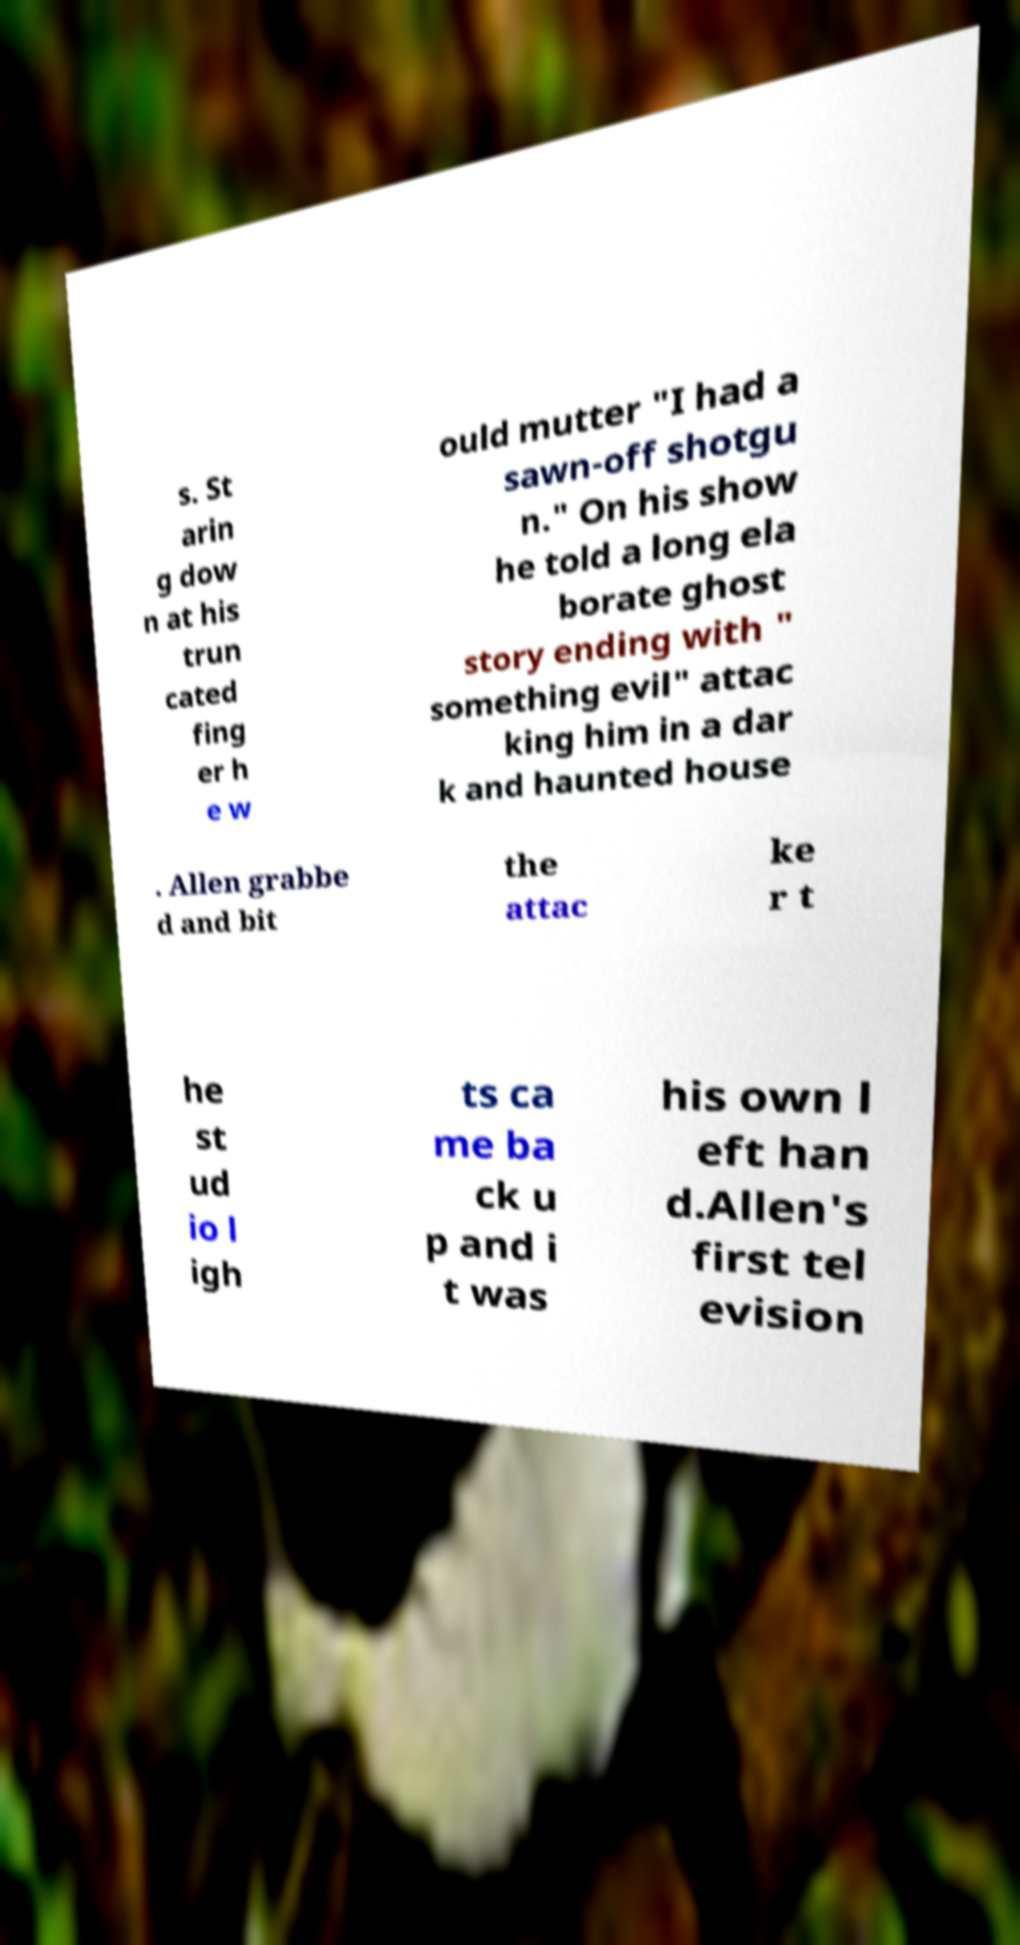For documentation purposes, I need the text within this image transcribed. Could you provide that? s. St arin g dow n at his trun cated fing er h e w ould mutter "I had a sawn-off shotgu n." On his show he told a long ela borate ghost story ending with " something evil" attac king him in a dar k and haunted house . Allen grabbe d and bit the attac ke r t he st ud io l igh ts ca me ba ck u p and i t was his own l eft han d.Allen's first tel evision 